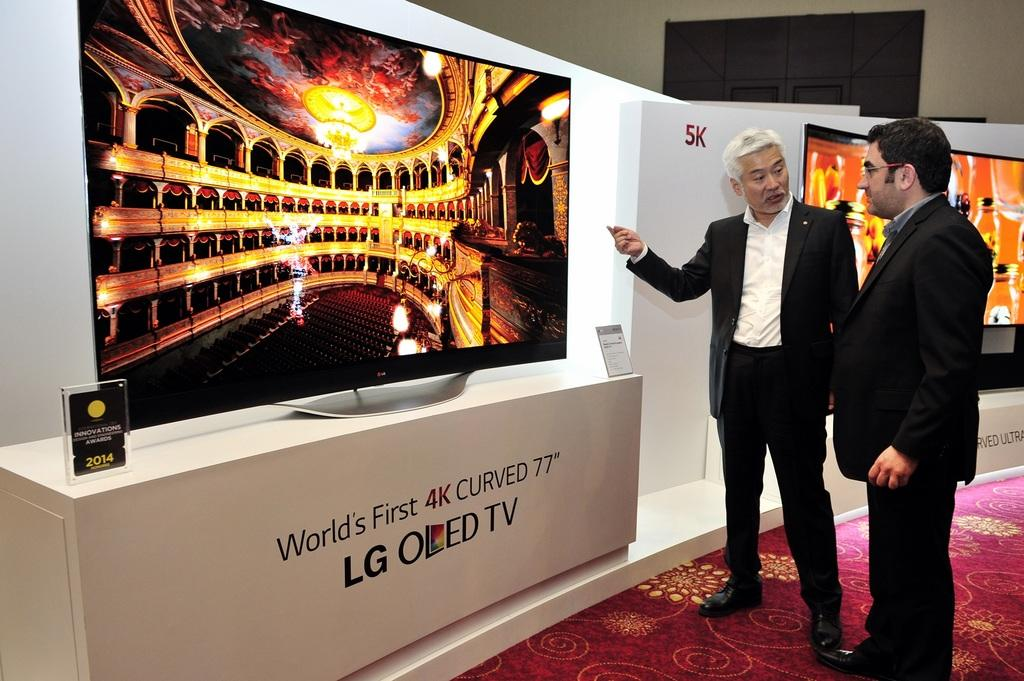Provide a one-sentence caption for the provided image. a person standing next to an LG sign near them. 